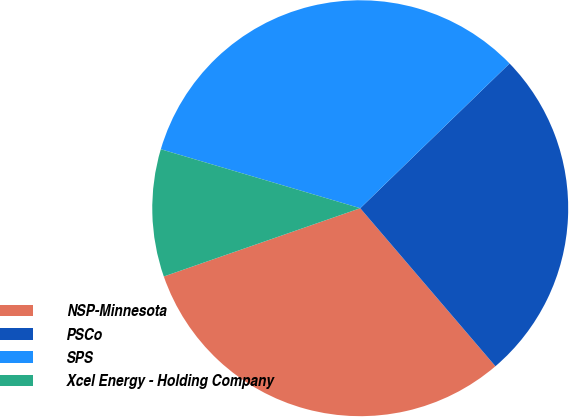<chart> <loc_0><loc_0><loc_500><loc_500><pie_chart><fcel>NSP-Minnesota<fcel>PSCo<fcel>SPS<fcel>Xcel Energy - Holding Company<nl><fcel>30.94%<fcel>25.99%<fcel>33.17%<fcel>9.9%<nl></chart> 